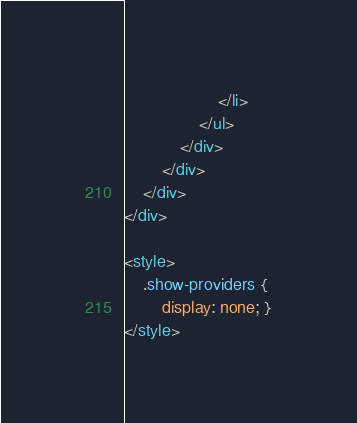Convert code to text. <code><loc_0><loc_0><loc_500><loc_500><_HTML_>					</li>
				</ul>
			</div>
		</div>
	</div>
</div>

<style>
	.show-providers {
		display: none; }
</style>

</code> 